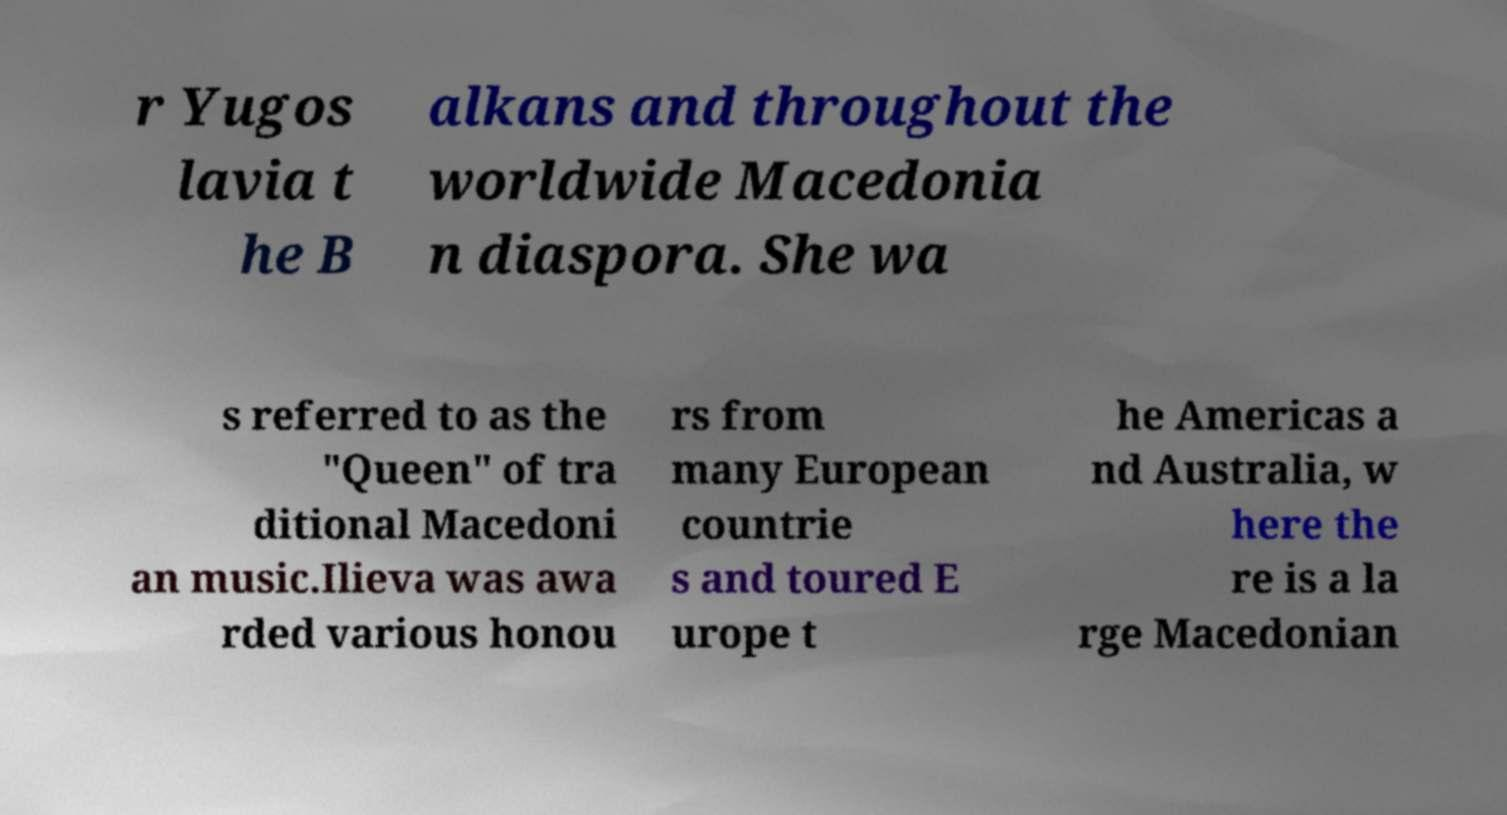For documentation purposes, I need the text within this image transcribed. Could you provide that? r Yugos lavia t he B alkans and throughout the worldwide Macedonia n diaspora. She wa s referred to as the "Queen" of tra ditional Macedoni an music.Ilieva was awa rded various honou rs from many European countrie s and toured E urope t he Americas a nd Australia, w here the re is a la rge Macedonian 